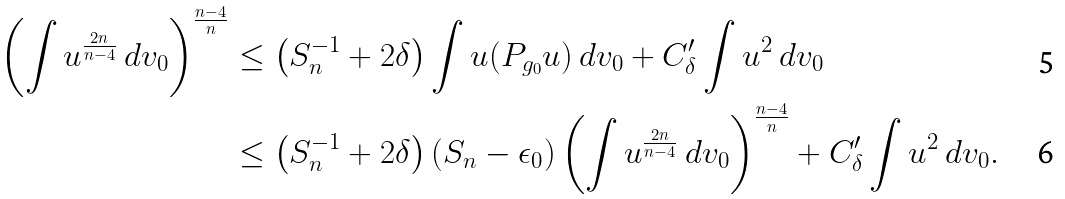<formula> <loc_0><loc_0><loc_500><loc_500>\left ( \int u ^ { \frac { 2 n } { n - 4 } } \ d v _ { 0 } \right ) ^ { \frac { n - 4 } { n } } & \leq \left ( S _ { n } ^ { - 1 } + 2 \delta \right ) \int u ( P _ { g _ { 0 } } u ) \ d v _ { 0 } + C _ { \delta } ^ { \prime } \int u ^ { 2 } \ d v _ { 0 } \\ & \leq \left ( S _ { n } ^ { - 1 } + 2 \delta \right ) \left ( S _ { n } - \epsilon _ { 0 } \right ) \left ( \int u ^ { \frac { 2 n } { n - 4 } } \ d v _ { 0 } \right ) ^ { \frac { n - 4 } { n } } + C _ { \delta } ^ { \prime } \int u ^ { 2 } \ d v _ { 0 } .</formula> 